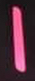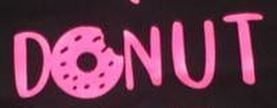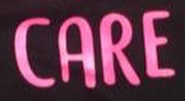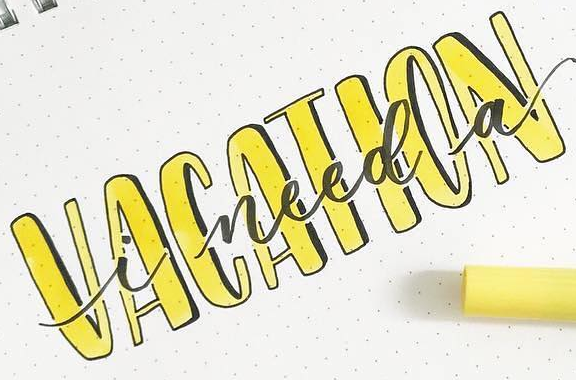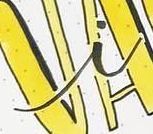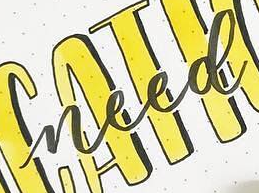Read the text content from these images in order, separated by a semicolon. I; DONUT; CARE; VACATION; i; need 